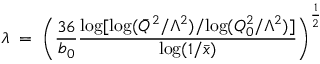Convert formula to latex. <formula><loc_0><loc_0><loc_500><loc_500>\lambda \, = \, \left ( \frac { 3 6 } { b _ { 0 } } \frac { \log [ \log ( \bar { Q } ^ { 2 } / \Lambda ^ { 2 } ) / \log ( Q _ { 0 } ^ { 2 } / \Lambda ^ { 2 } ) ] } { \log ( 1 / \bar { x } ) } \right ) ^ { \frac { 1 } { 2 } }</formula> 